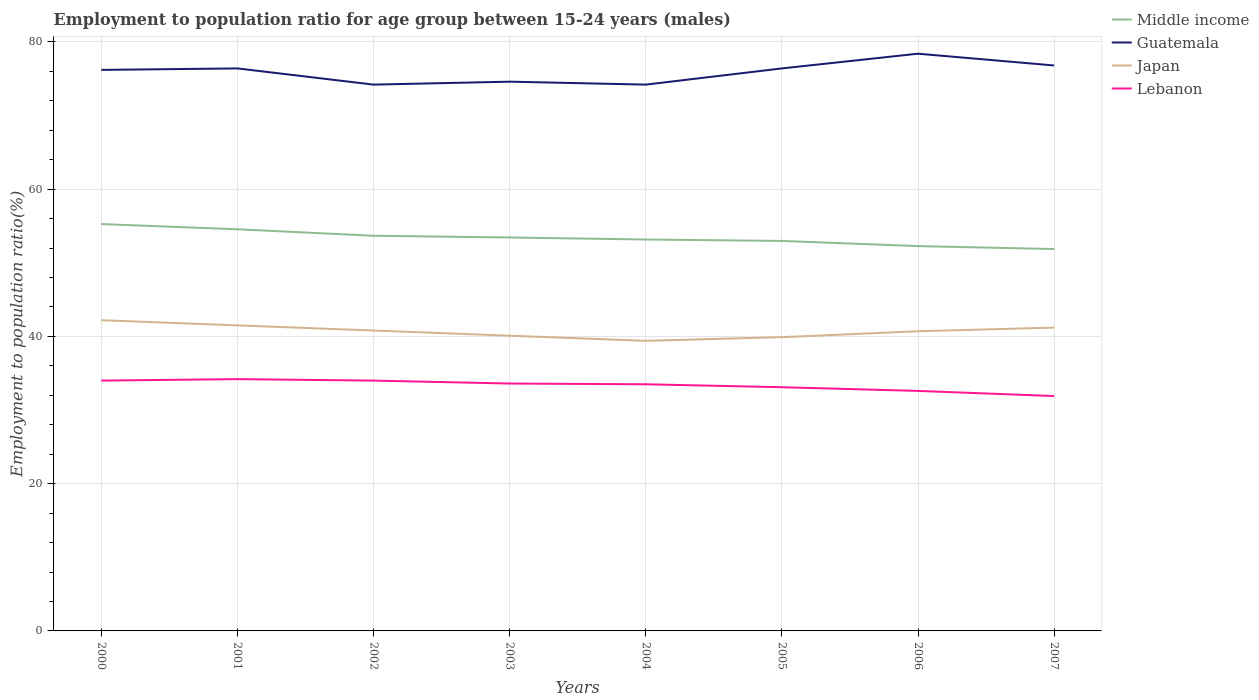Is the number of lines equal to the number of legend labels?
Keep it short and to the point. Yes. Across all years, what is the maximum employment to population ratio in Middle income?
Give a very brief answer. 51.87. What is the total employment to population ratio in Japan in the graph?
Offer a very short reply. -1.8. What is the difference between the highest and the second highest employment to population ratio in Middle income?
Your answer should be compact. 3.39. What is the difference between the highest and the lowest employment to population ratio in Guatemala?
Provide a short and direct response. 5. How many lines are there?
Keep it short and to the point. 4. How many years are there in the graph?
Keep it short and to the point. 8. What is the difference between two consecutive major ticks on the Y-axis?
Provide a short and direct response. 20. Are the values on the major ticks of Y-axis written in scientific E-notation?
Offer a terse response. No. Does the graph contain any zero values?
Ensure brevity in your answer.  No. Does the graph contain grids?
Keep it short and to the point. Yes. Where does the legend appear in the graph?
Give a very brief answer. Top right. How are the legend labels stacked?
Your response must be concise. Vertical. What is the title of the graph?
Provide a short and direct response. Employment to population ratio for age group between 15-24 years (males). Does "Solomon Islands" appear as one of the legend labels in the graph?
Offer a terse response. No. What is the label or title of the X-axis?
Ensure brevity in your answer.  Years. What is the Employment to population ratio(%) of Middle income in 2000?
Keep it short and to the point. 55.26. What is the Employment to population ratio(%) of Guatemala in 2000?
Your answer should be very brief. 76.2. What is the Employment to population ratio(%) in Japan in 2000?
Ensure brevity in your answer.  42.2. What is the Employment to population ratio(%) of Lebanon in 2000?
Offer a terse response. 34. What is the Employment to population ratio(%) in Middle income in 2001?
Keep it short and to the point. 54.55. What is the Employment to population ratio(%) in Guatemala in 2001?
Your response must be concise. 76.4. What is the Employment to population ratio(%) in Japan in 2001?
Your answer should be very brief. 41.5. What is the Employment to population ratio(%) in Lebanon in 2001?
Ensure brevity in your answer.  34.2. What is the Employment to population ratio(%) of Middle income in 2002?
Your response must be concise. 53.67. What is the Employment to population ratio(%) of Guatemala in 2002?
Offer a very short reply. 74.2. What is the Employment to population ratio(%) of Japan in 2002?
Keep it short and to the point. 40.8. What is the Employment to population ratio(%) in Middle income in 2003?
Offer a very short reply. 53.44. What is the Employment to population ratio(%) in Guatemala in 2003?
Give a very brief answer. 74.6. What is the Employment to population ratio(%) in Japan in 2003?
Give a very brief answer. 40.1. What is the Employment to population ratio(%) in Lebanon in 2003?
Your response must be concise. 33.6. What is the Employment to population ratio(%) in Middle income in 2004?
Keep it short and to the point. 53.16. What is the Employment to population ratio(%) of Guatemala in 2004?
Your answer should be compact. 74.2. What is the Employment to population ratio(%) in Japan in 2004?
Your answer should be very brief. 39.4. What is the Employment to population ratio(%) in Lebanon in 2004?
Provide a short and direct response. 33.5. What is the Employment to population ratio(%) in Middle income in 2005?
Your answer should be compact. 52.97. What is the Employment to population ratio(%) of Guatemala in 2005?
Provide a succinct answer. 76.4. What is the Employment to population ratio(%) of Japan in 2005?
Give a very brief answer. 39.9. What is the Employment to population ratio(%) of Lebanon in 2005?
Provide a succinct answer. 33.1. What is the Employment to population ratio(%) of Middle income in 2006?
Ensure brevity in your answer.  52.27. What is the Employment to population ratio(%) of Guatemala in 2006?
Ensure brevity in your answer.  78.4. What is the Employment to population ratio(%) of Japan in 2006?
Your answer should be very brief. 40.7. What is the Employment to population ratio(%) of Lebanon in 2006?
Give a very brief answer. 32.6. What is the Employment to population ratio(%) in Middle income in 2007?
Your answer should be compact. 51.87. What is the Employment to population ratio(%) in Guatemala in 2007?
Ensure brevity in your answer.  76.8. What is the Employment to population ratio(%) in Japan in 2007?
Offer a very short reply. 41.2. What is the Employment to population ratio(%) of Lebanon in 2007?
Ensure brevity in your answer.  31.9. Across all years, what is the maximum Employment to population ratio(%) of Middle income?
Offer a terse response. 55.26. Across all years, what is the maximum Employment to population ratio(%) in Guatemala?
Your answer should be compact. 78.4. Across all years, what is the maximum Employment to population ratio(%) of Japan?
Keep it short and to the point. 42.2. Across all years, what is the maximum Employment to population ratio(%) of Lebanon?
Your response must be concise. 34.2. Across all years, what is the minimum Employment to population ratio(%) in Middle income?
Provide a succinct answer. 51.87. Across all years, what is the minimum Employment to population ratio(%) in Guatemala?
Provide a short and direct response. 74.2. Across all years, what is the minimum Employment to population ratio(%) in Japan?
Keep it short and to the point. 39.4. Across all years, what is the minimum Employment to population ratio(%) of Lebanon?
Your response must be concise. 31.9. What is the total Employment to population ratio(%) of Middle income in the graph?
Give a very brief answer. 427.19. What is the total Employment to population ratio(%) of Guatemala in the graph?
Provide a succinct answer. 607.2. What is the total Employment to population ratio(%) of Japan in the graph?
Offer a terse response. 325.8. What is the total Employment to population ratio(%) in Lebanon in the graph?
Provide a succinct answer. 266.9. What is the difference between the Employment to population ratio(%) in Middle income in 2000 and that in 2001?
Ensure brevity in your answer.  0.71. What is the difference between the Employment to population ratio(%) of Lebanon in 2000 and that in 2001?
Offer a very short reply. -0.2. What is the difference between the Employment to population ratio(%) in Middle income in 2000 and that in 2002?
Offer a terse response. 1.59. What is the difference between the Employment to population ratio(%) in Guatemala in 2000 and that in 2002?
Ensure brevity in your answer.  2. What is the difference between the Employment to population ratio(%) in Middle income in 2000 and that in 2003?
Ensure brevity in your answer.  1.82. What is the difference between the Employment to population ratio(%) of Japan in 2000 and that in 2003?
Your answer should be very brief. 2.1. What is the difference between the Employment to population ratio(%) of Lebanon in 2000 and that in 2003?
Your answer should be compact. 0.4. What is the difference between the Employment to population ratio(%) in Middle income in 2000 and that in 2004?
Offer a terse response. 2.09. What is the difference between the Employment to population ratio(%) of Guatemala in 2000 and that in 2004?
Make the answer very short. 2. What is the difference between the Employment to population ratio(%) in Japan in 2000 and that in 2004?
Provide a succinct answer. 2.8. What is the difference between the Employment to population ratio(%) of Middle income in 2000 and that in 2005?
Ensure brevity in your answer.  2.29. What is the difference between the Employment to population ratio(%) of Guatemala in 2000 and that in 2005?
Keep it short and to the point. -0.2. What is the difference between the Employment to population ratio(%) of Japan in 2000 and that in 2005?
Offer a very short reply. 2.3. What is the difference between the Employment to population ratio(%) in Middle income in 2000 and that in 2006?
Provide a short and direct response. 2.99. What is the difference between the Employment to population ratio(%) of Guatemala in 2000 and that in 2006?
Ensure brevity in your answer.  -2.2. What is the difference between the Employment to population ratio(%) of Middle income in 2000 and that in 2007?
Your answer should be compact. 3.39. What is the difference between the Employment to population ratio(%) in Guatemala in 2000 and that in 2007?
Keep it short and to the point. -0.6. What is the difference between the Employment to population ratio(%) of Japan in 2000 and that in 2007?
Offer a very short reply. 1. What is the difference between the Employment to population ratio(%) of Lebanon in 2000 and that in 2007?
Provide a succinct answer. 2.1. What is the difference between the Employment to population ratio(%) of Middle income in 2001 and that in 2002?
Give a very brief answer. 0.88. What is the difference between the Employment to population ratio(%) of Guatemala in 2001 and that in 2002?
Your response must be concise. 2.2. What is the difference between the Employment to population ratio(%) in Middle income in 2001 and that in 2003?
Provide a succinct answer. 1.11. What is the difference between the Employment to population ratio(%) of Japan in 2001 and that in 2003?
Provide a short and direct response. 1.4. What is the difference between the Employment to population ratio(%) of Lebanon in 2001 and that in 2003?
Provide a short and direct response. 0.6. What is the difference between the Employment to population ratio(%) in Middle income in 2001 and that in 2004?
Offer a terse response. 1.39. What is the difference between the Employment to population ratio(%) in Japan in 2001 and that in 2004?
Provide a short and direct response. 2.1. What is the difference between the Employment to population ratio(%) in Middle income in 2001 and that in 2005?
Keep it short and to the point. 1.58. What is the difference between the Employment to population ratio(%) in Guatemala in 2001 and that in 2005?
Your answer should be very brief. 0. What is the difference between the Employment to population ratio(%) in Japan in 2001 and that in 2005?
Your answer should be very brief. 1.6. What is the difference between the Employment to population ratio(%) of Lebanon in 2001 and that in 2005?
Offer a very short reply. 1.1. What is the difference between the Employment to population ratio(%) in Middle income in 2001 and that in 2006?
Your answer should be very brief. 2.28. What is the difference between the Employment to population ratio(%) of Guatemala in 2001 and that in 2006?
Your answer should be very brief. -2. What is the difference between the Employment to population ratio(%) of Middle income in 2001 and that in 2007?
Offer a very short reply. 2.69. What is the difference between the Employment to population ratio(%) in Guatemala in 2001 and that in 2007?
Your response must be concise. -0.4. What is the difference between the Employment to population ratio(%) of Japan in 2001 and that in 2007?
Offer a terse response. 0.3. What is the difference between the Employment to population ratio(%) of Lebanon in 2001 and that in 2007?
Offer a terse response. 2.3. What is the difference between the Employment to population ratio(%) in Middle income in 2002 and that in 2003?
Ensure brevity in your answer.  0.24. What is the difference between the Employment to population ratio(%) in Guatemala in 2002 and that in 2003?
Provide a short and direct response. -0.4. What is the difference between the Employment to population ratio(%) in Japan in 2002 and that in 2003?
Provide a short and direct response. 0.7. What is the difference between the Employment to population ratio(%) in Lebanon in 2002 and that in 2003?
Your response must be concise. 0.4. What is the difference between the Employment to population ratio(%) of Middle income in 2002 and that in 2004?
Ensure brevity in your answer.  0.51. What is the difference between the Employment to population ratio(%) in Guatemala in 2002 and that in 2004?
Ensure brevity in your answer.  0. What is the difference between the Employment to population ratio(%) in Middle income in 2002 and that in 2005?
Offer a terse response. 0.7. What is the difference between the Employment to population ratio(%) of Lebanon in 2002 and that in 2005?
Your answer should be very brief. 0.9. What is the difference between the Employment to population ratio(%) of Middle income in 2002 and that in 2006?
Give a very brief answer. 1.4. What is the difference between the Employment to population ratio(%) of Lebanon in 2002 and that in 2006?
Your answer should be compact. 1.4. What is the difference between the Employment to population ratio(%) of Middle income in 2002 and that in 2007?
Offer a very short reply. 1.81. What is the difference between the Employment to population ratio(%) in Guatemala in 2002 and that in 2007?
Provide a short and direct response. -2.6. What is the difference between the Employment to population ratio(%) of Japan in 2002 and that in 2007?
Ensure brevity in your answer.  -0.4. What is the difference between the Employment to population ratio(%) in Middle income in 2003 and that in 2004?
Make the answer very short. 0.27. What is the difference between the Employment to population ratio(%) of Guatemala in 2003 and that in 2004?
Make the answer very short. 0.4. What is the difference between the Employment to population ratio(%) of Middle income in 2003 and that in 2005?
Offer a very short reply. 0.47. What is the difference between the Employment to population ratio(%) in Japan in 2003 and that in 2005?
Your answer should be very brief. 0.2. What is the difference between the Employment to population ratio(%) in Middle income in 2003 and that in 2006?
Your response must be concise. 1.17. What is the difference between the Employment to population ratio(%) of Guatemala in 2003 and that in 2006?
Ensure brevity in your answer.  -3.8. What is the difference between the Employment to population ratio(%) in Lebanon in 2003 and that in 2006?
Ensure brevity in your answer.  1. What is the difference between the Employment to population ratio(%) of Middle income in 2003 and that in 2007?
Provide a short and direct response. 1.57. What is the difference between the Employment to population ratio(%) in Guatemala in 2003 and that in 2007?
Your answer should be compact. -2.2. What is the difference between the Employment to population ratio(%) in Japan in 2003 and that in 2007?
Your response must be concise. -1.1. What is the difference between the Employment to population ratio(%) of Lebanon in 2003 and that in 2007?
Offer a terse response. 1.7. What is the difference between the Employment to population ratio(%) in Middle income in 2004 and that in 2005?
Provide a short and direct response. 0.19. What is the difference between the Employment to population ratio(%) in Guatemala in 2004 and that in 2005?
Provide a succinct answer. -2.2. What is the difference between the Employment to population ratio(%) of Lebanon in 2004 and that in 2005?
Keep it short and to the point. 0.4. What is the difference between the Employment to population ratio(%) of Middle income in 2004 and that in 2006?
Offer a terse response. 0.9. What is the difference between the Employment to population ratio(%) of Japan in 2004 and that in 2006?
Provide a succinct answer. -1.3. What is the difference between the Employment to population ratio(%) of Lebanon in 2004 and that in 2006?
Provide a succinct answer. 0.9. What is the difference between the Employment to population ratio(%) of Middle income in 2004 and that in 2007?
Offer a very short reply. 1.3. What is the difference between the Employment to population ratio(%) in Middle income in 2005 and that in 2006?
Offer a terse response. 0.7. What is the difference between the Employment to population ratio(%) in Guatemala in 2005 and that in 2006?
Provide a succinct answer. -2. What is the difference between the Employment to population ratio(%) of Lebanon in 2005 and that in 2006?
Provide a short and direct response. 0.5. What is the difference between the Employment to population ratio(%) in Middle income in 2005 and that in 2007?
Provide a succinct answer. 1.1. What is the difference between the Employment to population ratio(%) of Lebanon in 2005 and that in 2007?
Make the answer very short. 1.2. What is the difference between the Employment to population ratio(%) in Middle income in 2006 and that in 2007?
Offer a very short reply. 0.4. What is the difference between the Employment to population ratio(%) of Guatemala in 2006 and that in 2007?
Offer a very short reply. 1.6. What is the difference between the Employment to population ratio(%) in Japan in 2006 and that in 2007?
Ensure brevity in your answer.  -0.5. What is the difference between the Employment to population ratio(%) in Middle income in 2000 and the Employment to population ratio(%) in Guatemala in 2001?
Your response must be concise. -21.14. What is the difference between the Employment to population ratio(%) in Middle income in 2000 and the Employment to population ratio(%) in Japan in 2001?
Provide a succinct answer. 13.76. What is the difference between the Employment to population ratio(%) in Middle income in 2000 and the Employment to population ratio(%) in Lebanon in 2001?
Keep it short and to the point. 21.06. What is the difference between the Employment to population ratio(%) of Guatemala in 2000 and the Employment to population ratio(%) of Japan in 2001?
Provide a short and direct response. 34.7. What is the difference between the Employment to population ratio(%) in Middle income in 2000 and the Employment to population ratio(%) in Guatemala in 2002?
Your answer should be very brief. -18.94. What is the difference between the Employment to population ratio(%) of Middle income in 2000 and the Employment to population ratio(%) of Japan in 2002?
Offer a very short reply. 14.46. What is the difference between the Employment to population ratio(%) in Middle income in 2000 and the Employment to population ratio(%) in Lebanon in 2002?
Make the answer very short. 21.26. What is the difference between the Employment to population ratio(%) in Guatemala in 2000 and the Employment to population ratio(%) in Japan in 2002?
Give a very brief answer. 35.4. What is the difference between the Employment to population ratio(%) of Guatemala in 2000 and the Employment to population ratio(%) of Lebanon in 2002?
Your answer should be compact. 42.2. What is the difference between the Employment to population ratio(%) of Japan in 2000 and the Employment to population ratio(%) of Lebanon in 2002?
Your answer should be compact. 8.2. What is the difference between the Employment to population ratio(%) in Middle income in 2000 and the Employment to population ratio(%) in Guatemala in 2003?
Offer a very short reply. -19.34. What is the difference between the Employment to population ratio(%) in Middle income in 2000 and the Employment to population ratio(%) in Japan in 2003?
Your response must be concise. 15.16. What is the difference between the Employment to population ratio(%) in Middle income in 2000 and the Employment to population ratio(%) in Lebanon in 2003?
Keep it short and to the point. 21.66. What is the difference between the Employment to population ratio(%) in Guatemala in 2000 and the Employment to population ratio(%) in Japan in 2003?
Provide a short and direct response. 36.1. What is the difference between the Employment to population ratio(%) of Guatemala in 2000 and the Employment to population ratio(%) of Lebanon in 2003?
Offer a terse response. 42.6. What is the difference between the Employment to population ratio(%) of Japan in 2000 and the Employment to population ratio(%) of Lebanon in 2003?
Your response must be concise. 8.6. What is the difference between the Employment to population ratio(%) of Middle income in 2000 and the Employment to population ratio(%) of Guatemala in 2004?
Provide a succinct answer. -18.94. What is the difference between the Employment to population ratio(%) in Middle income in 2000 and the Employment to population ratio(%) in Japan in 2004?
Provide a succinct answer. 15.86. What is the difference between the Employment to population ratio(%) of Middle income in 2000 and the Employment to population ratio(%) of Lebanon in 2004?
Your answer should be very brief. 21.76. What is the difference between the Employment to population ratio(%) in Guatemala in 2000 and the Employment to population ratio(%) in Japan in 2004?
Offer a very short reply. 36.8. What is the difference between the Employment to population ratio(%) in Guatemala in 2000 and the Employment to population ratio(%) in Lebanon in 2004?
Your answer should be very brief. 42.7. What is the difference between the Employment to population ratio(%) in Middle income in 2000 and the Employment to population ratio(%) in Guatemala in 2005?
Your response must be concise. -21.14. What is the difference between the Employment to population ratio(%) in Middle income in 2000 and the Employment to population ratio(%) in Japan in 2005?
Your answer should be compact. 15.36. What is the difference between the Employment to population ratio(%) of Middle income in 2000 and the Employment to population ratio(%) of Lebanon in 2005?
Provide a short and direct response. 22.16. What is the difference between the Employment to population ratio(%) in Guatemala in 2000 and the Employment to population ratio(%) in Japan in 2005?
Your answer should be compact. 36.3. What is the difference between the Employment to population ratio(%) of Guatemala in 2000 and the Employment to population ratio(%) of Lebanon in 2005?
Your response must be concise. 43.1. What is the difference between the Employment to population ratio(%) in Japan in 2000 and the Employment to population ratio(%) in Lebanon in 2005?
Provide a succinct answer. 9.1. What is the difference between the Employment to population ratio(%) in Middle income in 2000 and the Employment to population ratio(%) in Guatemala in 2006?
Provide a succinct answer. -23.14. What is the difference between the Employment to population ratio(%) in Middle income in 2000 and the Employment to population ratio(%) in Japan in 2006?
Offer a terse response. 14.56. What is the difference between the Employment to population ratio(%) of Middle income in 2000 and the Employment to population ratio(%) of Lebanon in 2006?
Keep it short and to the point. 22.66. What is the difference between the Employment to population ratio(%) in Guatemala in 2000 and the Employment to population ratio(%) in Japan in 2006?
Offer a terse response. 35.5. What is the difference between the Employment to population ratio(%) of Guatemala in 2000 and the Employment to population ratio(%) of Lebanon in 2006?
Provide a succinct answer. 43.6. What is the difference between the Employment to population ratio(%) in Japan in 2000 and the Employment to population ratio(%) in Lebanon in 2006?
Provide a short and direct response. 9.6. What is the difference between the Employment to population ratio(%) of Middle income in 2000 and the Employment to population ratio(%) of Guatemala in 2007?
Offer a terse response. -21.54. What is the difference between the Employment to population ratio(%) in Middle income in 2000 and the Employment to population ratio(%) in Japan in 2007?
Your answer should be very brief. 14.06. What is the difference between the Employment to population ratio(%) in Middle income in 2000 and the Employment to population ratio(%) in Lebanon in 2007?
Ensure brevity in your answer.  23.36. What is the difference between the Employment to population ratio(%) in Guatemala in 2000 and the Employment to population ratio(%) in Lebanon in 2007?
Offer a terse response. 44.3. What is the difference between the Employment to population ratio(%) of Middle income in 2001 and the Employment to population ratio(%) of Guatemala in 2002?
Your response must be concise. -19.65. What is the difference between the Employment to population ratio(%) of Middle income in 2001 and the Employment to population ratio(%) of Japan in 2002?
Your answer should be very brief. 13.75. What is the difference between the Employment to population ratio(%) in Middle income in 2001 and the Employment to population ratio(%) in Lebanon in 2002?
Your answer should be very brief. 20.55. What is the difference between the Employment to population ratio(%) in Guatemala in 2001 and the Employment to population ratio(%) in Japan in 2002?
Your answer should be very brief. 35.6. What is the difference between the Employment to population ratio(%) in Guatemala in 2001 and the Employment to population ratio(%) in Lebanon in 2002?
Your answer should be compact. 42.4. What is the difference between the Employment to population ratio(%) of Japan in 2001 and the Employment to population ratio(%) of Lebanon in 2002?
Provide a succinct answer. 7.5. What is the difference between the Employment to population ratio(%) in Middle income in 2001 and the Employment to population ratio(%) in Guatemala in 2003?
Your answer should be compact. -20.05. What is the difference between the Employment to population ratio(%) of Middle income in 2001 and the Employment to population ratio(%) of Japan in 2003?
Provide a succinct answer. 14.45. What is the difference between the Employment to population ratio(%) in Middle income in 2001 and the Employment to population ratio(%) in Lebanon in 2003?
Make the answer very short. 20.95. What is the difference between the Employment to population ratio(%) in Guatemala in 2001 and the Employment to population ratio(%) in Japan in 2003?
Make the answer very short. 36.3. What is the difference between the Employment to population ratio(%) of Guatemala in 2001 and the Employment to population ratio(%) of Lebanon in 2003?
Offer a terse response. 42.8. What is the difference between the Employment to population ratio(%) in Japan in 2001 and the Employment to population ratio(%) in Lebanon in 2003?
Provide a succinct answer. 7.9. What is the difference between the Employment to population ratio(%) in Middle income in 2001 and the Employment to population ratio(%) in Guatemala in 2004?
Provide a short and direct response. -19.65. What is the difference between the Employment to population ratio(%) in Middle income in 2001 and the Employment to population ratio(%) in Japan in 2004?
Offer a terse response. 15.15. What is the difference between the Employment to population ratio(%) of Middle income in 2001 and the Employment to population ratio(%) of Lebanon in 2004?
Your answer should be very brief. 21.05. What is the difference between the Employment to population ratio(%) in Guatemala in 2001 and the Employment to population ratio(%) in Lebanon in 2004?
Give a very brief answer. 42.9. What is the difference between the Employment to population ratio(%) of Middle income in 2001 and the Employment to population ratio(%) of Guatemala in 2005?
Offer a very short reply. -21.85. What is the difference between the Employment to population ratio(%) of Middle income in 2001 and the Employment to population ratio(%) of Japan in 2005?
Provide a succinct answer. 14.65. What is the difference between the Employment to population ratio(%) in Middle income in 2001 and the Employment to population ratio(%) in Lebanon in 2005?
Provide a succinct answer. 21.45. What is the difference between the Employment to population ratio(%) of Guatemala in 2001 and the Employment to population ratio(%) of Japan in 2005?
Your response must be concise. 36.5. What is the difference between the Employment to population ratio(%) in Guatemala in 2001 and the Employment to population ratio(%) in Lebanon in 2005?
Offer a terse response. 43.3. What is the difference between the Employment to population ratio(%) of Middle income in 2001 and the Employment to population ratio(%) of Guatemala in 2006?
Keep it short and to the point. -23.85. What is the difference between the Employment to population ratio(%) of Middle income in 2001 and the Employment to population ratio(%) of Japan in 2006?
Keep it short and to the point. 13.85. What is the difference between the Employment to population ratio(%) in Middle income in 2001 and the Employment to population ratio(%) in Lebanon in 2006?
Keep it short and to the point. 21.95. What is the difference between the Employment to population ratio(%) in Guatemala in 2001 and the Employment to population ratio(%) in Japan in 2006?
Ensure brevity in your answer.  35.7. What is the difference between the Employment to population ratio(%) in Guatemala in 2001 and the Employment to population ratio(%) in Lebanon in 2006?
Ensure brevity in your answer.  43.8. What is the difference between the Employment to population ratio(%) in Japan in 2001 and the Employment to population ratio(%) in Lebanon in 2006?
Make the answer very short. 8.9. What is the difference between the Employment to population ratio(%) of Middle income in 2001 and the Employment to population ratio(%) of Guatemala in 2007?
Make the answer very short. -22.25. What is the difference between the Employment to population ratio(%) in Middle income in 2001 and the Employment to population ratio(%) in Japan in 2007?
Provide a succinct answer. 13.35. What is the difference between the Employment to population ratio(%) of Middle income in 2001 and the Employment to population ratio(%) of Lebanon in 2007?
Provide a short and direct response. 22.65. What is the difference between the Employment to population ratio(%) of Guatemala in 2001 and the Employment to population ratio(%) of Japan in 2007?
Give a very brief answer. 35.2. What is the difference between the Employment to population ratio(%) in Guatemala in 2001 and the Employment to population ratio(%) in Lebanon in 2007?
Make the answer very short. 44.5. What is the difference between the Employment to population ratio(%) in Japan in 2001 and the Employment to population ratio(%) in Lebanon in 2007?
Provide a short and direct response. 9.6. What is the difference between the Employment to population ratio(%) in Middle income in 2002 and the Employment to population ratio(%) in Guatemala in 2003?
Provide a short and direct response. -20.93. What is the difference between the Employment to population ratio(%) in Middle income in 2002 and the Employment to population ratio(%) in Japan in 2003?
Your answer should be very brief. 13.57. What is the difference between the Employment to population ratio(%) of Middle income in 2002 and the Employment to population ratio(%) of Lebanon in 2003?
Give a very brief answer. 20.07. What is the difference between the Employment to population ratio(%) in Guatemala in 2002 and the Employment to population ratio(%) in Japan in 2003?
Ensure brevity in your answer.  34.1. What is the difference between the Employment to population ratio(%) of Guatemala in 2002 and the Employment to population ratio(%) of Lebanon in 2003?
Make the answer very short. 40.6. What is the difference between the Employment to population ratio(%) in Middle income in 2002 and the Employment to population ratio(%) in Guatemala in 2004?
Give a very brief answer. -20.53. What is the difference between the Employment to population ratio(%) of Middle income in 2002 and the Employment to population ratio(%) of Japan in 2004?
Your answer should be very brief. 14.27. What is the difference between the Employment to population ratio(%) in Middle income in 2002 and the Employment to population ratio(%) in Lebanon in 2004?
Ensure brevity in your answer.  20.17. What is the difference between the Employment to population ratio(%) of Guatemala in 2002 and the Employment to population ratio(%) of Japan in 2004?
Ensure brevity in your answer.  34.8. What is the difference between the Employment to population ratio(%) in Guatemala in 2002 and the Employment to population ratio(%) in Lebanon in 2004?
Keep it short and to the point. 40.7. What is the difference between the Employment to population ratio(%) of Middle income in 2002 and the Employment to population ratio(%) of Guatemala in 2005?
Keep it short and to the point. -22.73. What is the difference between the Employment to population ratio(%) of Middle income in 2002 and the Employment to population ratio(%) of Japan in 2005?
Give a very brief answer. 13.77. What is the difference between the Employment to population ratio(%) in Middle income in 2002 and the Employment to population ratio(%) in Lebanon in 2005?
Offer a very short reply. 20.57. What is the difference between the Employment to population ratio(%) of Guatemala in 2002 and the Employment to population ratio(%) of Japan in 2005?
Provide a short and direct response. 34.3. What is the difference between the Employment to population ratio(%) of Guatemala in 2002 and the Employment to population ratio(%) of Lebanon in 2005?
Your answer should be compact. 41.1. What is the difference between the Employment to population ratio(%) in Japan in 2002 and the Employment to population ratio(%) in Lebanon in 2005?
Your response must be concise. 7.7. What is the difference between the Employment to population ratio(%) of Middle income in 2002 and the Employment to population ratio(%) of Guatemala in 2006?
Your answer should be compact. -24.73. What is the difference between the Employment to population ratio(%) in Middle income in 2002 and the Employment to population ratio(%) in Japan in 2006?
Your response must be concise. 12.97. What is the difference between the Employment to population ratio(%) in Middle income in 2002 and the Employment to population ratio(%) in Lebanon in 2006?
Your answer should be compact. 21.07. What is the difference between the Employment to population ratio(%) in Guatemala in 2002 and the Employment to population ratio(%) in Japan in 2006?
Keep it short and to the point. 33.5. What is the difference between the Employment to population ratio(%) in Guatemala in 2002 and the Employment to population ratio(%) in Lebanon in 2006?
Offer a very short reply. 41.6. What is the difference between the Employment to population ratio(%) in Middle income in 2002 and the Employment to population ratio(%) in Guatemala in 2007?
Ensure brevity in your answer.  -23.13. What is the difference between the Employment to population ratio(%) in Middle income in 2002 and the Employment to population ratio(%) in Japan in 2007?
Keep it short and to the point. 12.47. What is the difference between the Employment to population ratio(%) of Middle income in 2002 and the Employment to population ratio(%) of Lebanon in 2007?
Give a very brief answer. 21.77. What is the difference between the Employment to population ratio(%) of Guatemala in 2002 and the Employment to population ratio(%) of Japan in 2007?
Your response must be concise. 33. What is the difference between the Employment to population ratio(%) in Guatemala in 2002 and the Employment to population ratio(%) in Lebanon in 2007?
Your response must be concise. 42.3. What is the difference between the Employment to population ratio(%) in Middle income in 2003 and the Employment to population ratio(%) in Guatemala in 2004?
Provide a succinct answer. -20.76. What is the difference between the Employment to population ratio(%) of Middle income in 2003 and the Employment to population ratio(%) of Japan in 2004?
Your answer should be very brief. 14.04. What is the difference between the Employment to population ratio(%) of Middle income in 2003 and the Employment to population ratio(%) of Lebanon in 2004?
Provide a short and direct response. 19.94. What is the difference between the Employment to population ratio(%) of Guatemala in 2003 and the Employment to population ratio(%) of Japan in 2004?
Your answer should be very brief. 35.2. What is the difference between the Employment to population ratio(%) in Guatemala in 2003 and the Employment to population ratio(%) in Lebanon in 2004?
Keep it short and to the point. 41.1. What is the difference between the Employment to population ratio(%) of Middle income in 2003 and the Employment to population ratio(%) of Guatemala in 2005?
Ensure brevity in your answer.  -22.96. What is the difference between the Employment to population ratio(%) in Middle income in 2003 and the Employment to population ratio(%) in Japan in 2005?
Give a very brief answer. 13.54. What is the difference between the Employment to population ratio(%) of Middle income in 2003 and the Employment to population ratio(%) of Lebanon in 2005?
Provide a short and direct response. 20.34. What is the difference between the Employment to population ratio(%) in Guatemala in 2003 and the Employment to population ratio(%) in Japan in 2005?
Ensure brevity in your answer.  34.7. What is the difference between the Employment to population ratio(%) in Guatemala in 2003 and the Employment to population ratio(%) in Lebanon in 2005?
Provide a short and direct response. 41.5. What is the difference between the Employment to population ratio(%) of Middle income in 2003 and the Employment to population ratio(%) of Guatemala in 2006?
Your answer should be compact. -24.96. What is the difference between the Employment to population ratio(%) of Middle income in 2003 and the Employment to population ratio(%) of Japan in 2006?
Provide a succinct answer. 12.74. What is the difference between the Employment to population ratio(%) in Middle income in 2003 and the Employment to population ratio(%) in Lebanon in 2006?
Offer a very short reply. 20.84. What is the difference between the Employment to population ratio(%) of Guatemala in 2003 and the Employment to population ratio(%) of Japan in 2006?
Make the answer very short. 33.9. What is the difference between the Employment to population ratio(%) in Guatemala in 2003 and the Employment to population ratio(%) in Lebanon in 2006?
Your answer should be compact. 42. What is the difference between the Employment to population ratio(%) in Middle income in 2003 and the Employment to population ratio(%) in Guatemala in 2007?
Your answer should be compact. -23.36. What is the difference between the Employment to population ratio(%) in Middle income in 2003 and the Employment to population ratio(%) in Japan in 2007?
Make the answer very short. 12.24. What is the difference between the Employment to population ratio(%) in Middle income in 2003 and the Employment to population ratio(%) in Lebanon in 2007?
Make the answer very short. 21.54. What is the difference between the Employment to population ratio(%) in Guatemala in 2003 and the Employment to population ratio(%) in Japan in 2007?
Give a very brief answer. 33.4. What is the difference between the Employment to population ratio(%) in Guatemala in 2003 and the Employment to population ratio(%) in Lebanon in 2007?
Keep it short and to the point. 42.7. What is the difference between the Employment to population ratio(%) in Japan in 2003 and the Employment to population ratio(%) in Lebanon in 2007?
Make the answer very short. 8.2. What is the difference between the Employment to population ratio(%) in Middle income in 2004 and the Employment to population ratio(%) in Guatemala in 2005?
Your response must be concise. -23.24. What is the difference between the Employment to population ratio(%) of Middle income in 2004 and the Employment to population ratio(%) of Japan in 2005?
Your response must be concise. 13.26. What is the difference between the Employment to population ratio(%) in Middle income in 2004 and the Employment to population ratio(%) in Lebanon in 2005?
Offer a terse response. 20.06. What is the difference between the Employment to population ratio(%) of Guatemala in 2004 and the Employment to population ratio(%) of Japan in 2005?
Ensure brevity in your answer.  34.3. What is the difference between the Employment to population ratio(%) in Guatemala in 2004 and the Employment to population ratio(%) in Lebanon in 2005?
Ensure brevity in your answer.  41.1. What is the difference between the Employment to population ratio(%) in Middle income in 2004 and the Employment to population ratio(%) in Guatemala in 2006?
Offer a very short reply. -25.24. What is the difference between the Employment to population ratio(%) in Middle income in 2004 and the Employment to population ratio(%) in Japan in 2006?
Ensure brevity in your answer.  12.46. What is the difference between the Employment to population ratio(%) in Middle income in 2004 and the Employment to population ratio(%) in Lebanon in 2006?
Make the answer very short. 20.56. What is the difference between the Employment to population ratio(%) in Guatemala in 2004 and the Employment to population ratio(%) in Japan in 2006?
Provide a succinct answer. 33.5. What is the difference between the Employment to population ratio(%) in Guatemala in 2004 and the Employment to population ratio(%) in Lebanon in 2006?
Offer a very short reply. 41.6. What is the difference between the Employment to population ratio(%) of Middle income in 2004 and the Employment to population ratio(%) of Guatemala in 2007?
Provide a succinct answer. -23.64. What is the difference between the Employment to population ratio(%) in Middle income in 2004 and the Employment to population ratio(%) in Japan in 2007?
Make the answer very short. 11.96. What is the difference between the Employment to population ratio(%) of Middle income in 2004 and the Employment to population ratio(%) of Lebanon in 2007?
Give a very brief answer. 21.26. What is the difference between the Employment to population ratio(%) in Guatemala in 2004 and the Employment to population ratio(%) in Japan in 2007?
Give a very brief answer. 33. What is the difference between the Employment to population ratio(%) of Guatemala in 2004 and the Employment to population ratio(%) of Lebanon in 2007?
Your answer should be compact. 42.3. What is the difference between the Employment to population ratio(%) of Japan in 2004 and the Employment to population ratio(%) of Lebanon in 2007?
Keep it short and to the point. 7.5. What is the difference between the Employment to population ratio(%) of Middle income in 2005 and the Employment to population ratio(%) of Guatemala in 2006?
Your answer should be compact. -25.43. What is the difference between the Employment to population ratio(%) of Middle income in 2005 and the Employment to population ratio(%) of Japan in 2006?
Provide a short and direct response. 12.27. What is the difference between the Employment to population ratio(%) in Middle income in 2005 and the Employment to population ratio(%) in Lebanon in 2006?
Provide a short and direct response. 20.37. What is the difference between the Employment to population ratio(%) in Guatemala in 2005 and the Employment to population ratio(%) in Japan in 2006?
Your answer should be compact. 35.7. What is the difference between the Employment to population ratio(%) of Guatemala in 2005 and the Employment to population ratio(%) of Lebanon in 2006?
Your answer should be compact. 43.8. What is the difference between the Employment to population ratio(%) of Middle income in 2005 and the Employment to population ratio(%) of Guatemala in 2007?
Keep it short and to the point. -23.83. What is the difference between the Employment to population ratio(%) of Middle income in 2005 and the Employment to population ratio(%) of Japan in 2007?
Your response must be concise. 11.77. What is the difference between the Employment to population ratio(%) in Middle income in 2005 and the Employment to population ratio(%) in Lebanon in 2007?
Offer a very short reply. 21.07. What is the difference between the Employment to population ratio(%) in Guatemala in 2005 and the Employment to population ratio(%) in Japan in 2007?
Your answer should be very brief. 35.2. What is the difference between the Employment to population ratio(%) of Guatemala in 2005 and the Employment to population ratio(%) of Lebanon in 2007?
Ensure brevity in your answer.  44.5. What is the difference between the Employment to population ratio(%) in Middle income in 2006 and the Employment to population ratio(%) in Guatemala in 2007?
Provide a short and direct response. -24.53. What is the difference between the Employment to population ratio(%) of Middle income in 2006 and the Employment to population ratio(%) of Japan in 2007?
Offer a terse response. 11.07. What is the difference between the Employment to population ratio(%) in Middle income in 2006 and the Employment to population ratio(%) in Lebanon in 2007?
Ensure brevity in your answer.  20.37. What is the difference between the Employment to population ratio(%) in Guatemala in 2006 and the Employment to population ratio(%) in Japan in 2007?
Provide a short and direct response. 37.2. What is the difference between the Employment to population ratio(%) in Guatemala in 2006 and the Employment to population ratio(%) in Lebanon in 2007?
Give a very brief answer. 46.5. What is the average Employment to population ratio(%) of Middle income per year?
Keep it short and to the point. 53.4. What is the average Employment to population ratio(%) of Guatemala per year?
Provide a short and direct response. 75.9. What is the average Employment to population ratio(%) of Japan per year?
Offer a very short reply. 40.73. What is the average Employment to population ratio(%) of Lebanon per year?
Your answer should be compact. 33.36. In the year 2000, what is the difference between the Employment to population ratio(%) in Middle income and Employment to population ratio(%) in Guatemala?
Give a very brief answer. -20.94. In the year 2000, what is the difference between the Employment to population ratio(%) of Middle income and Employment to population ratio(%) of Japan?
Give a very brief answer. 13.06. In the year 2000, what is the difference between the Employment to population ratio(%) in Middle income and Employment to population ratio(%) in Lebanon?
Make the answer very short. 21.26. In the year 2000, what is the difference between the Employment to population ratio(%) of Guatemala and Employment to population ratio(%) of Lebanon?
Your response must be concise. 42.2. In the year 2000, what is the difference between the Employment to population ratio(%) of Japan and Employment to population ratio(%) of Lebanon?
Your answer should be compact. 8.2. In the year 2001, what is the difference between the Employment to population ratio(%) of Middle income and Employment to population ratio(%) of Guatemala?
Give a very brief answer. -21.85. In the year 2001, what is the difference between the Employment to population ratio(%) of Middle income and Employment to population ratio(%) of Japan?
Keep it short and to the point. 13.05. In the year 2001, what is the difference between the Employment to population ratio(%) of Middle income and Employment to population ratio(%) of Lebanon?
Ensure brevity in your answer.  20.35. In the year 2001, what is the difference between the Employment to population ratio(%) of Guatemala and Employment to population ratio(%) of Japan?
Your response must be concise. 34.9. In the year 2001, what is the difference between the Employment to population ratio(%) in Guatemala and Employment to population ratio(%) in Lebanon?
Offer a very short reply. 42.2. In the year 2001, what is the difference between the Employment to population ratio(%) of Japan and Employment to population ratio(%) of Lebanon?
Keep it short and to the point. 7.3. In the year 2002, what is the difference between the Employment to population ratio(%) in Middle income and Employment to population ratio(%) in Guatemala?
Provide a succinct answer. -20.53. In the year 2002, what is the difference between the Employment to population ratio(%) of Middle income and Employment to population ratio(%) of Japan?
Provide a short and direct response. 12.87. In the year 2002, what is the difference between the Employment to population ratio(%) in Middle income and Employment to population ratio(%) in Lebanon?
Offer a very short reply. 19.67. In the year 2002, what is the difference between the Employment to population ratio(%) of Guatemala and Employment to population ratio(%) of Japan?
Offer a very short reply. 33.4. In the year 2002, what is the difference between the Employment to population ratio(%) of Guatemala and Employment to population ratio(%) of Lebanon?
Your answer should be compact. 40.2. In the year 2002, what is the difference between the Employment to population ratio(%) of Japan and Employment to population ratio(%) of Lebanon?
Offer a terse response. 6.8. In the year 2003, what is the difference between the Employment to population ratio(%) in Middle income and Employment to population ratio(%) in Guatemala?
Offer a terse response. -21.16. In the year 2003, what is the difference between the Employment to population ratio(%) of Middle income and Employment to population ratio(%) of Japan?
Your response must be concise. 13.34. In the year 2003, what is the difference between the Employment to population ratio(%) in Middle income and Employment to population ratio(%) in Lebanon?
Make the answer very short. 19.84. In the year 2003, what is the difference between the Employment to population ratio(%) in Guatemala and Employment to population ratio(%) in Japan?
Provide a succinct answer. 34.5. In the year 2003, what is the difference between the Employment to population ratio(%) of Japan and Employment to population ratio(%) of Lebanon?
Offer a terse response. 6.5. In the year 2004, what is the difference between the Employment to population ratio(%) of Middle income and Employment to population ratio(%) of Guatemala?
Give a very brief answer. -21.04. In the year 2004, what is the difference between the Employment to population ratio(%) of Middle income and Employment to population ratio(%) of Japan?
Your answer should be very brief. 13.76. In the year 2004, what is the difference between the Employment to population ratio(%) of Middle income and Employment to population ratio(%) of Lebanon?
Your answer should be compact. 19.66. In the year 2004, what is the difference between the Employment to population ratio(%) in Guatemala and Employment to population ratio(%) in Japan?
Ensure brevity in your answer.  34.8. In the year 2004, what is the difference between the Employment to population ratio(%) of Guatemala and Employment to population ratio(%) of Lebanon?
Keep it short and to the point. 40.7. In the year 2005, what is the difference between the Employment to population ratio(%) of Middle income and Employment to population ratio(%) of Guatemala?
Offer a very short reply. -23.43. In the year 2005, what is the difference between the Employment to population ratio(%) of Middle income and Employment to population ratio(%) of Japan?
Provide a succinct answer. 13.07. In the year 2005, what is the difference between the Employment to population ratio(%) of Middle income and Employment to population ratio(%) of Lebanon?
Offer a very short reply. 19.87. In the year 2005, what is the difference between the Employment to population ratio(%) in Guatemala and Employment to population ratio(%) in Japan?
Your response must be concise. 36.5. In the year 2005, what is the difference between the Employment to population ratio(%) in Guatemala and Employment to population ratio(%) in Lebanon?
Offer a very short reply. 43.3. In the year 2006, what is the difference between the Employment to population ratio(%) of Middle income and Employment to population ratio(%) of Guatemala?
Ensure brevity in your answer.  -26.13. In the year 2006, what is the difference between the Employment to population ratio(%) of Middle income and Employment to population ratio(%) of Japan?
Keep it short and to the point. 11.57. In the year 2006, what is the difference between the Employment to population ratio(%) of Middle income and Employment to population ratio(%) of Lebanon?
Keep it short and to the point. 19.67. In the year 2006, what is the difference between the Employment to population ratio(%) in Guatemala and Employment to population ratio(%) in Japan?
Provide a succinct answer. 37.7. In the year 2006, what is the difference between the Employment to population ratio(%) of Guatemala and Employment to population ratio(%) of Lebanon?
Offer a very short reply. 45.8. In the year 2006, what is the difference between the Employment to population ratio(%) of Japan and Employment to population ratio(%) of Lebanon?
Keep it short and to the point. 8.1. In the year 2007, what is the difference between the Employment to population ratio(%) of Middle income and Employment to population ratio(%) of Guatemala?
Your response must be concise. -24.93. In the year 2007, what is the difference between the Employment to population ratio(%) of Middle income and Employment to population ratio(%) of Japan?
Your answer should be very brief. 10.67. In the year 2007, what is the difference between the Employment to population ratio(%) of Middle income and Employment to population ratio(%) of Lebanon?
Offer a terse response. 19.97. In the year 2007, what is the difference between the Employment to population ratio(%) in Guatemala and Employment to population ratio(%) in Japan?
Provide a succinct answer. 35.6. In the year 2007, what is the difference between the Employment to population ratio(%) of Guatemala and Employment to population ratio(%) of Lebanon?
Ensure brevity in your answer.  44.9. In the year 2007, what is the difference between the Employment to population ratio(%) in Japan and Employment to population ratio(%) in Lebanon?
Keep it short and to the point. 9.3. What is the ratio of the Employment to population ratio(%) in Middle income in 2000 to that in 2001?
Offer a very short reply. 1.01. What is the ratio of the Employment to population ratio(%) in Guatemala in 2000 to that in 2001?
Ensure brevity in your answer.  1. What is the ratio of the Employment to population ratio(%) in Japan in 2000 to that in 2001?
Provide a short and direct response. 1.02. What is the ratio of the Employment to population ratio(%) of Lebanon in 2000 to that in 2001?
Keep it short and to the point. 0.99. What is the ratio of the Employment to population ratio(%) of Middle income in 2000 to that in 2002?
Provide a succinct answer. 1.03. What is the ratio of the Employment to population ratio(%) in Guatemala in 2000 to that in 2002?
Ensure brevity in your answer.  1.03. What is the ratio of the Employment to population ratio(%) in Japan in 2000 to that in 2002?
Provide a succinct answer. 1.03. What is the ratio of the Employment to population ratio(%) in Lebanon in 2000 to that in 2002?
Your response must be concise. 1. What is the ratio of the Employment to population ratio(%) of Middle income in 2000 to that in 2003?
Offer a terse response. 1.03. What is the ratio of the Employment to population ratio(%) in Guatemala in 2000 to that in 2003?
Your answer should be very brief. 1.02. What is the ratio of the Employment to population ratio(%) in Japan in 2000 to that in 2003?
Your answer should be very brief. 1.05. What is the ratio of the Employment to population ratio(%) in Lebanon in 2000 to that in 2003?
Make the answer very short. 1.01. What is the ratio of the Employment to population ratio(%) of Middle income in 2000 to that in 2004?
Provide a short and direct response. 1.04. What is the ratio of the Employment to population ratio(%) of Guatemala in 2000 to that in 2004?
Make the answer very short. 1.03. What is the ratio of the Employment to population ratio(%) in Japan in 2000 to that in 2004?
Ensure brevity in your answer.  1.07. What is the ratio of the Employment to population ratio(%) in Lebanon in 2000 to that in 2004?
Your answer should be very brief. 1.01. What is the ratio of the Employment to population ratio(%) of Middle income in 2000 to that in 2005?
Give a very brief answer. 1.04. What is the ratio of the Employment to population ratio(%) of Japan in 2000 to that in 2005?
Offer a very short reply. 1.06. What is the ratio of the Employment to population ratio(%) of Lebanon in 2000 to that in 2005?
Your answer should be very brief. 1.03. What is the ratio of the Employment to population ratio(%) in Middle income in 2000 to that in 2006?
Keep it short and to the point. 1.06. What is the ratio of the Employment to population ratio(%) in Guatemala in 2000 to that in 2006?
Offer a very short reply. 0.97. What is the ratio of the Employment to population ratio(%) in Japan in 2000 to that in 2006?
Ensure brevity in your answer.  1.04. What is the ratio of the Employment to population ratio(%) in Lebanon in 2000 to that in 2006?
Offer a very short reply. 1.04. What is the ratio of the Employment to population ratio(%) of Middle income in 2000 to that in 2007?
Your answer should be compact. 1.07. What is the ratio of the Employment to population ratio(%) of Guatemala in 2000 to that in 2007?
Keep it short and to the point. 0.99. What is the ratio of the Employment to population ratio(%) of Japan in 2000 to that in 2007?
Make the answer very short. 1.02. What is the ratio of the Employment to population ratio(%) of Lebanon in 2000 to that in 2007?
Offer a very short reply. 1.07. What is the ratio of the Employment to population ratio(%) of Middle income in 2001 to that in 2002?
Provide a short and direct response. 1.02. What is the ratio of the Employment to population ratio(%) of Guatemala in 2001 to that in 2002?
Provide a succinct answer. 1.03. What is the ratio of the Employment to population ratio(%) in Japan in 2001 to that in 2002?
Offer a terse response. 1.02. What is the ratio of the Employment to population ratio(%) of Lebanon in 2001 to that in 2002?
Keep it short and to the point. 1.01. What is the ratio of the Employment to population ratio(%) of Middle income in 2001 to that in 2003?
Provide a succinct answer. 1.02. What is the ratio of the Employment to population ratio(%) in Guatemala in 2001 to that in 2003?
Offer a very short reply. 1.02. What is the ratio of the Employment to population ratio(%) in Japan in 2001 to that in 2003?
Your answer should be very brief. 1.03. What is the ratio of the Employment to population ratio(%) in Lebanon in 2001 to that in 2003?
Offer a terse response. 1.02. What is the ratio of the Employment to population ratio(%) in Middle income in 2001 to that in 2004?
Make the answer very short. 1.03. What is the ratio of the Employment to population ratio(%) in Guatemala in 2001 to that in 2004?
Keep it short and to the point. 1.03. What is the ratio of the Employment to population ratio(%) of Japan in 2001 to that in 2004?
Provide a succinct answer. 1.05. What is the ratio of the Employment to population ratio(%) of Lebanon in 2001 to that in 2004?
Ensure brevity in your answer.  1.02. What is the ratio of the Employment to population ratio(%) of Middle income in 2001 to that in 2005?
Provide a succinct answer. 1.03. What is the ratio of the Employment to population ratio(%) of Japan in 2001 to that in 2005?
Your response must be concise. 1.04. What is the ratio of the Employment to population ratio(%) in Lebanon in 2001 to that in 2005?
Give a very brief answer. 1.03. What is the ratio of the Employment to population ratio(%) in Middle income in 2001 to that in 2006?
Offer a very short reply. 1.04. What is the ratio of the Employment to population ratio(%) in Guatemala in 2001 to that in 2006?
Ensure brevity in your answer.  0.97. What is the ratio of the Employment to population ratio(%) of Japan in 2001 to that in 2006?
Keep it short and to the point. 1.02. What is the ratio of the Employment to population ratio(%) of Lebanon in 2001 to that in 2006?
Offer a very short reply. 1.05. What is the ratio of the Employment to population ratio(%) of Middle income in 2001 to that in 2007?
Keep it short and to the point. 1.05. What is the ratio of the Employment to population ratio(%) of Guatemala in 2001 to that in 2007?
Offer a very short reply. 0.99. What is the ratio of the Employment to population ratio(%) in Japan in 2001 to that in 2007?
Ensure brevity in your answer.  1.01. What is the ratio of the Employment to population ratio(%) in Lebanon in 2001 to that in 2007?
Keep it short and to the point. 1.07. What is the ratio of the Employment to population ratio(%) in Guatemala in 2002 to that in 2003?
Keep it short and to the point. 0.99. What is the ratio of the Employment to population ratio(%) of Japan in 2002 to that in 2003?
Keep it short and to the point. 1.02. What is the ratio of the Employment to population ratio(%) of Lebanon in 2002 to that in 2003?
Give a very brief answer. 1.01. What is the ratio of the Employment to population ratio(%) of Middle income in 2002 to that in 2004?
Your answer should be very brief. 1.01. What is the ratio of the Employment to population ratio(%) of Guatemala in 2002 to that in 2004?
Offer a very short reply. 1. What is the ratio of the Employment to population ratio(%) in Japan in 2002 to that in 2004?
Your answer should be compact. 1.04. What is the ratio of the Employment to population ratio(%) of Lebanon in 2002 to that in 2004?
Provide a short and direct response. 1.01. What is the ratio of the Employment to population ratio(%) of Middle income in 2002 to that in 2005?
Provide a short and direct response. 1.01. What is the ratio of the Employment to population ratio(%) in Guatemala in 2002 to that in 2005?
Your response must be concise. 0.97. What is the ratio of the Employment to population ratio(%) of Japan in 2002 to that in 2005?
Your answer should be compact. 1.02. What is the ratio of the Employment to population ratio(%) in Lebanon in 2002 to that in 2005?
Make the answer very short. 1.03. What is the ratio of the Employment to population ratio(%) in Middle income in 2002 to that in 2006?
Provide a succinct answer. 1.03. What is the ratio of the Employment to population ratio(%) in Guatemala in 2002 to that in 2006?
Your answer should be very brief. 0.95. What is the ratio of the Employment to population ratio(%) of Japan in 2002 to that in 2006?
Your answer should be very brief. 1. What is the ratio of the Employment to population ratio(%) in Lebanon in 2002 to that in 2006?
Your answer should be compact. 1.04. What is the ratio of the Employment to population ratio(%) of Middle income in 2002 to that in 2007?
Provide a short and direct response. 1.03. What is the ratio of the Employment to population ratio(%) of Guatemala in 2002 to that in 2007?
Offer a terse response. 0.97. What is the ratio of the Employment to population ratio(%) in Japan in 2002 to that in 2007?
Give a very brief answer. 0.99. What is the ratio of the Employment to population ratio(%) of Lebanon in 2002 to that in 2007?
Your answer should be compact. 1.07. What is the ratio of the Employment to population ratio(%) in Middle income in 2003 to that in 2004?
Offer a very short reply. 1.01. What is the ratio of the Employment to population ratio(%) in Guatemala in 2003 to that in 2004?
Provide a short and direct response. 1.01. What is the ratio of the Employment to population ratio(%) of Japan in 2003 to that in 2004?
Your answer should be very brief. 1.02. What is the ratio of the Employment to population ratio(%) in Lebanon in 2003 to that in 2004?
Offer a terse response. 1. What is the ratio of the Employment to population ratio(%) of Middle income in 2003 to that in 2005?
Provide a succinct answer. 1.01. What is the ratio of the Employment to population ratio(%) of Guatemala in 2003 to that in 2005?
Keep it short and to the point. 0.98. What is the ratio of the Employment to population ratio(%) of Lebanon in 2003 to that in 2005?
Your answer should be compact. 1.02. What is the ratio of the Employment to population ratio(%) in Middle income in 2003 to that in 2006?
Make the answer very short. 1.02. What is the ratio of the Employment to population ratio(%) in Guatemala in 2003 to that in 2006?
Provide a succinct answer. 0.95. What is the ratio of the Employment to population ratio(%) of Lebanon in 2003 to that in 2006?
Provide a short and direct response. 1.03. What is the ratio of the Employment to population ratio(%) of Middle income in 2003 to that in 2007?
Provide a succinct answer. 1.03. What is the ratio of the Employment to population ratio(%) of Guatemala in 2003 to that in 2007?
Ensure brevity in your answer.  0.97. What is the ratio of the Employment to population ratio(%) of Japan in 2003 to that in 2007?
Your response must be concise. 0.97. What is the ratio of the Employment to population ratio(%) of Lebanon in 2003 to that in 2007?
Your answer should be very brief. 1.05. What is the ratio of the Employment to population ratio(%) of Guatemala in 2004 to that in 2005?
Offer a terse response. 0.97. What is the ratio of the Employment to population ratio(%) in Japan in 2004 to that in 2005?
Your answer should be compact. 0.99. What is the ratio of the Employment to population ratio(%) in Lebanon in 2004 to that in 2005?
Offer a terse response. 1.01. What is the ratio of the Employment to population ratio(%) of Middle income in 2004 to that in 2006?
Make the answer very short. 1.02. What is the ratio of the Employment to population ratio(%) of Guatemala in 2004 to that in 2006?
Ensure brevity in your answer.  0.95. What is the ratio of the Employment to population ratio(%) in Japan in 2004 to that in 2006?
Keep it short and to the point. 0.97. What is the ratio of the Employment to population ratio(%) in Lebanon in 2004 to that in 2006?
Give a very brief answer. 1.03. What is the ratio of the Employment to population ratio(%) in Guatemala in 2004 to that in 2007?
Provide a short and direct response. 0.97. What is the ratio of the Employment to population ratio(%) in Japan in 2004 to that in 2007?
Your answer should be very brief. 0.96. What is the ratio of the Employment to population ratio(%) of Lebanon in 2004 to that in 2007?
Your answer should be very brief. 1.05. What is the ratio of the Employment to population ratio(%) of Middle income in 2005 to that in 2006?
Your answer should be very brief. 1.01. What is the ratio of the Employment to population ratio(%) in Guatemala in 2005 to that in 2006?
Ensure brevity in your answer.  0.97. What is the ratio of the Employment to population ratio(%) of Japan in 2005 to that in 2006?
Your response must be concise. 0.98. What is the ratio of the Employment to population ratio(%) of Lebanon in 2005 to that in 2006?
Your response must be concise. 1.02. What is the ratio of the Employment to population ratio(%) of Middle income in 2005 to that in 2007?
Your response must be concise. 1.02. What is the ratio of the Employment to population ratio(%) in Japan in 2005 to that in 2007?
Provide a succinct answer. 0.97. What is the ratio of the Employment to population ratio(%) of Lebanon in 2005 to that in 2007?
Your answer should be compact. 1.04. What is the ratio of the Employment to population ratio(%) of Guatemala in 2006 to that in 2007?
Make the answer very short. 1.02. What is the ratio of the Employment to population ratio(%) in Japan in 2006 to that in 2007?
Offer a very short reply. 0.99. What is the ratio of the Employment to population ratio(%) in Lebanon in 2006 to that in 2007?
Your response must be concise. 1.02. What is the difference between the highest and the second highest Employment to population ratio(%) of Middle income?
Your answer should be very brief. 0.71. What is the difference between the highest and the second highest Employment to population ratio(%) in Guatemala?
Ensure brevity in your answer.  1.6. What is the difference between the highest and the lowest Employment to population ratio(%) of Middle income?
Offer a very short reply. 3.39. What is the difference between the highest and the lowest Employment to population ratio(%) in Guatemala?
Your answer should be very brief. 4.2. 